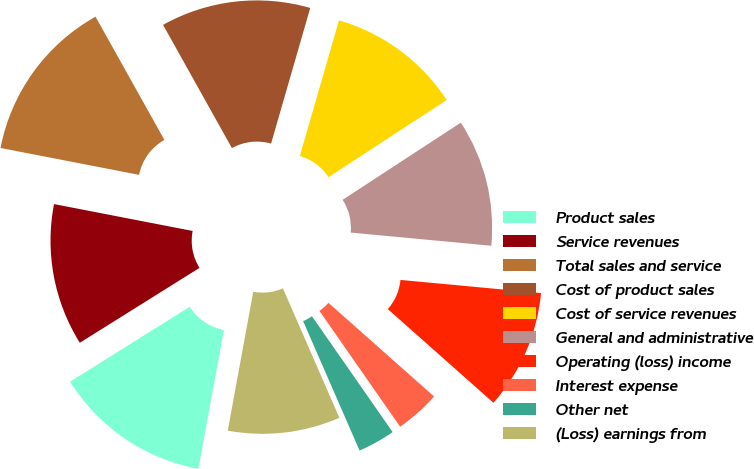Convert chart. <chart><loc_0><loc_0><loc_500><loc_500><pie_chart><fcel>Product sales<fcel>Service revenues<fcel>Total sales and service<fcel>Cost of product sales<fcel>Cost of service revenues<fcel>General and administrative<fcel>Operating (loss) income<fcel>Interest expense<fcel>Other net<fcel>(Loss) earnings from<nl><fcel>13.21%<fcel>11.95%<fcel>13.84%<fcel>12.58%<fcel>11.32%<fcel>10.69%<fcel>10.06%<fcel>3.77%<fcel>3.14%<fcel>9.43%<nl></chart> 